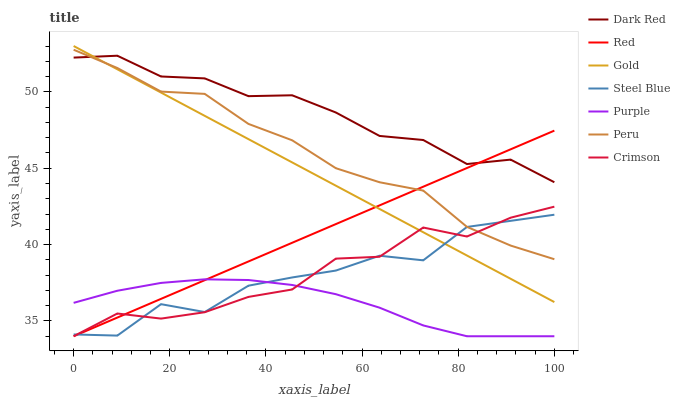Does Purple have the minimum area under the curve?
Answer yes or no. Yes. Does Dark Red have the maximum area under the curve?
Answer yes or no. Yes. Does Dark Red have the minimum area under the curve?
Answer yes or no. No. Does Purple have the maximum area under the curve?
Answer yes or no. No. Is Gold the smoothest?
Answer yes or no. Yes. Is Steel Blue the roughest?
Answer yes or no. Yes. Is Purple the smoothest?
Answer yes or no. No. Is Purple the roughest?
Answer yes or no. No. Does Purple have the lowest value?
Answer yes or no. Yes. Does Dark Red have the lowest value?
Answer yes or no. No. Does Gold have the highest value?
Answer yes or no. Yes. Does Dark Red have the highest value?
Answer yes or no. No. Is Purple less than Dark Red?
Answer yes or no. Yes. Is Dark Red greater than Steel Blue?
Answer yes or no. Yes. Does Red intersect Steel Blue?
Answer yes or no. Yes. Is Red less than Steel Blue?
Answer yes or no. No. Is Red greater than Steel Blue?
Answer yes or no. No. Does Purple intersect Dark Red?
Answer yes or no. No. 